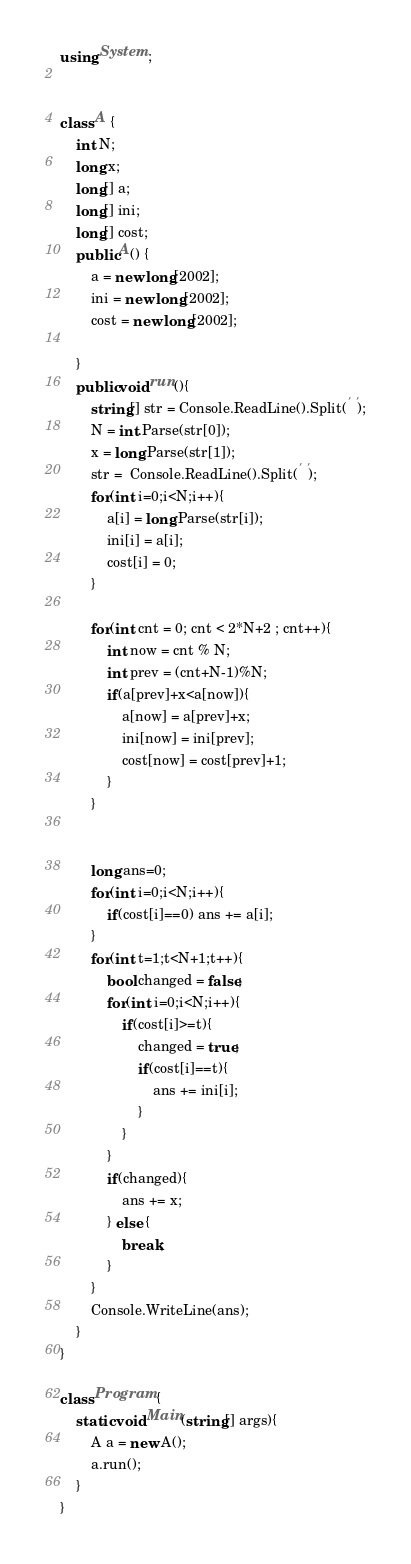Convert code to text. <code><loc_0><loc_0><loc_500><loc_500><_C#_>using System;


class A {
    int N;
    long x;
    long[] a;
    long[] ini;
    long[] cost;
    public A() {
        a = new long[2002];
        ini = new long[2002];
        cost = new long[2002];
        
    }
    public void run(){
        string[] str = Console.ReadLine().Split(' ');
        N = int.Parse(str[0]);
        x = long.Parse(str[1]);
        str =  Console.ReadLine().Split(' ');
        for(int i=0;i<N;i++){
            a[i] = long.Parse(str[i]);
            ini[i] = a[i];
            cost[i] = 0;
        }
        
        for(int cnt = 0; cnt < 2*N+2 ; cnt++){
            int now = cnt % N;
            int prev = (cnt+N-1)%N;
            if(a[prev]+x<a[now]){
                a[now] = a[prev]+x;
                ini[now] = ini[prev];
                cost[now] = cost[prev]+1; 
            }
        }
        
        
        long ans=0;
        for(int i=0;i<N;i++){
            if(cost[i]==0) ans += a[i];
        }
        for(int t=1;t<N+1;t++){
            bool changed = false;
            for(int i=0;i<N;i++){
                if(cost[i]>=t){
                    changed = true;
                    if(cost[i]==t){
                        ans += ini[i];
                    }
                }
            }
            if(changed){
                ans += x;
            } else {
                break;
            }
        }
        Console.WriteLine(ans);
    }
}

class Program {
    static void Main(string[] args){
        A a = new A();
        a.run();
    }
}</code> 